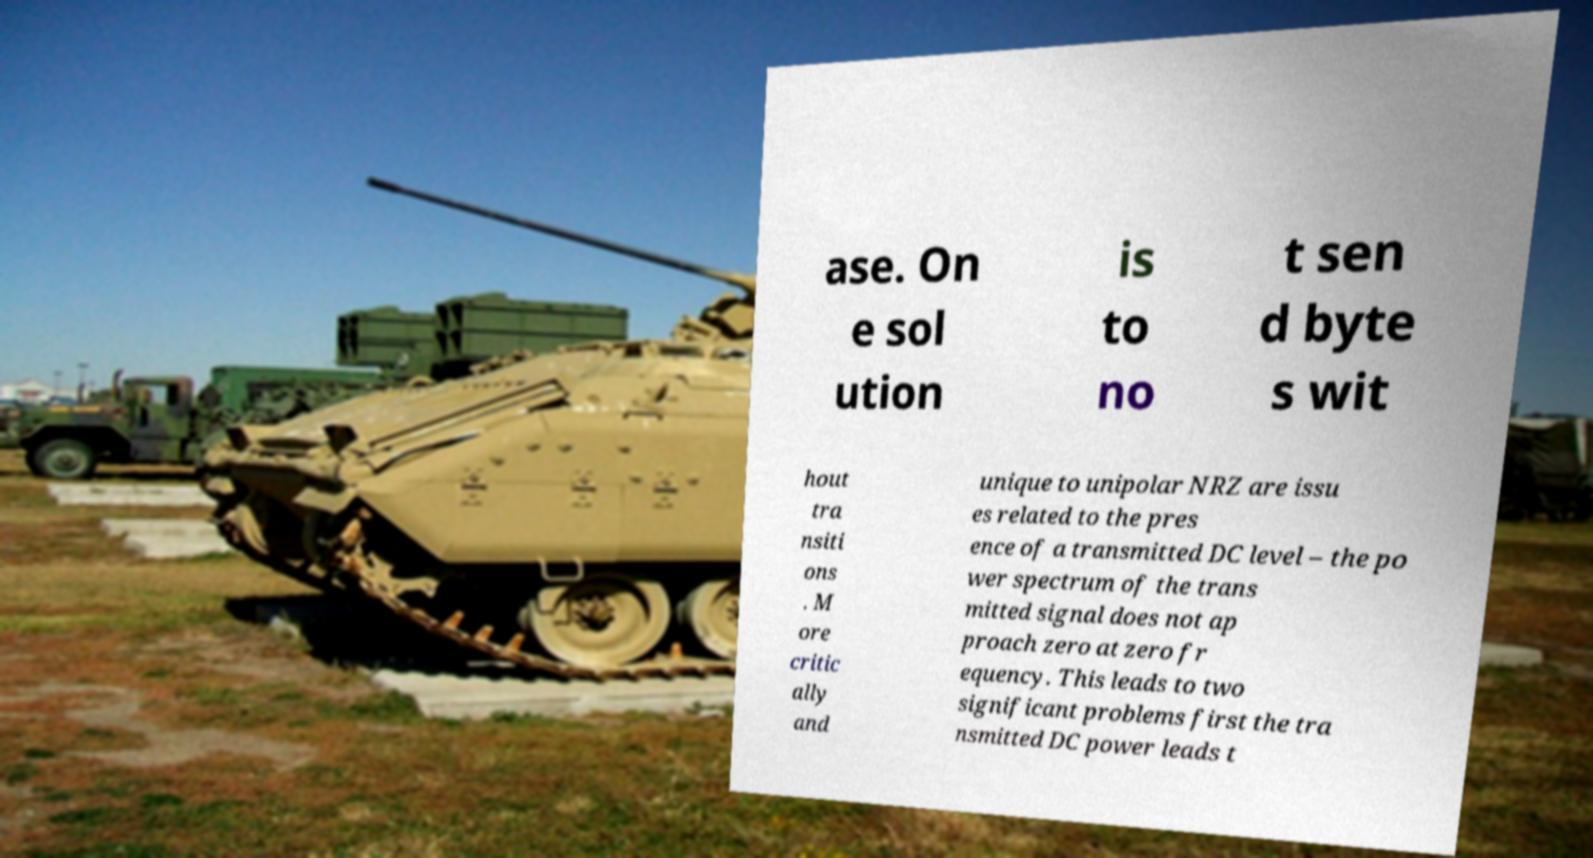Could you extract and type out the text from this image? ase. On e sol ution is to no t sen d byte s wit hout tra nsiti ons . M ore critic ally and unique to unipolar NRZ are issu es related to the pres ence of a transmitted DC level – the po wer spectrum of the trans mitted signal does not ap proach zero at zero fr equency. This leads to two significant problems first the tra nsmitted DC power leads t 